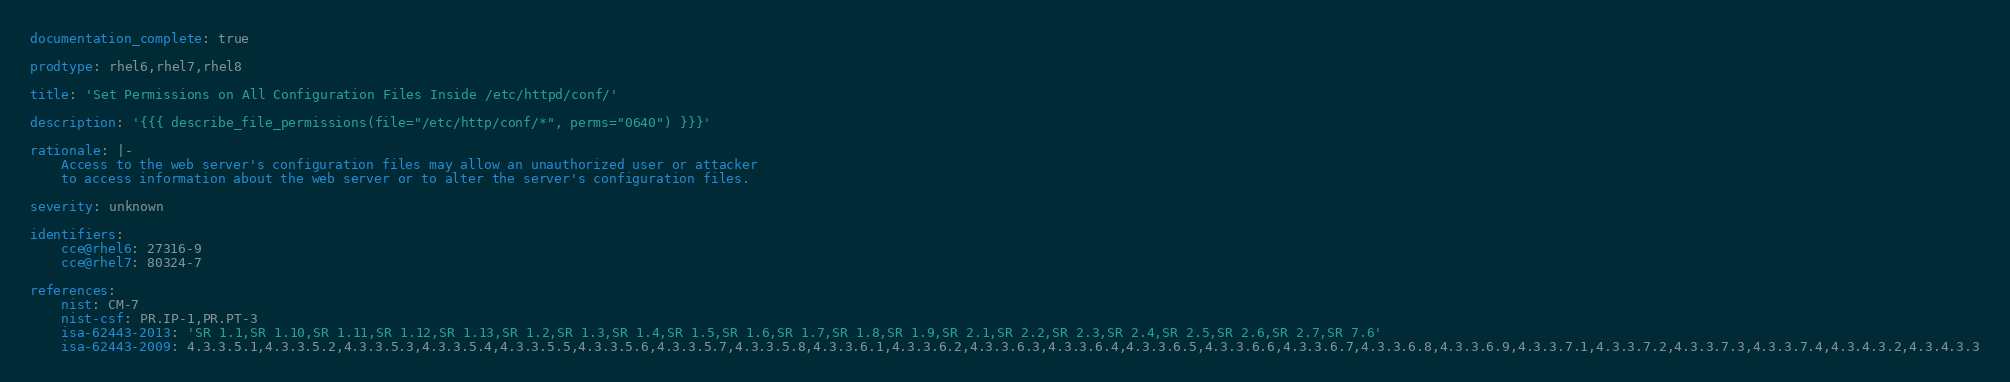<code> <loc_0><loc_0><loc_500><loc_500><_YAML_>documentation_complete: true

prodtype: rhel6,rhel7,rhel8

title: 'Set Permissions on All Configuration Files Inside /etc/httpd/conf/'

description: '{{{ describe_file_permissions(file="/etc/http/conf/*", perms="0640") }}}'

rationale: |-
    Access to the web server's configuration files may allow an unauthorized user or attacker
    to access information about the web server or to alter the server's configuration files.

severity: unknown

identifiers:
    cce@rhel6: 27316-9
    cce@rhel7: 80324-7

references:
    nist: CM-7
    nist-csf: PR.IP-1,PR.PT-3
    isa-62443-2013: 'SR 1.1,SR 1.10,SR 1.11,SR 1.12,SR 1.13,SR 1.2,SR 1.3,SR 1.4,SR 1.5,SR 1.6,SR 1.7,SR 1.8,SR 1.9,SR 2.1,SR 2.2,SR 2.3,SR 2.4,SR 2.5,SR 2.6,SR 2.7,SR 7.6'
    isa-62443-2009: 4.3.3.5.1,4.3.3.5.2,4.3.3.5.3,4.3.3.5.4,4.3.3.5.5,4.3.3.5.6,4.3.3.5.7,4.3.3.5.8,4.3.3.6.1,4.3.3.6.2,4.3.3.6.3,4.3.3.6.4,4.3.3.6.5,4.3.3.6.6,4.3.3.6.7,4.3.3.6.8,4.3.3.6.9,4.3.3.7.1,4.3.3.7.2,4.3.3.7.3,4.3.3.7.4,4.3.4.3.2,4.3.4.3.3</code> 